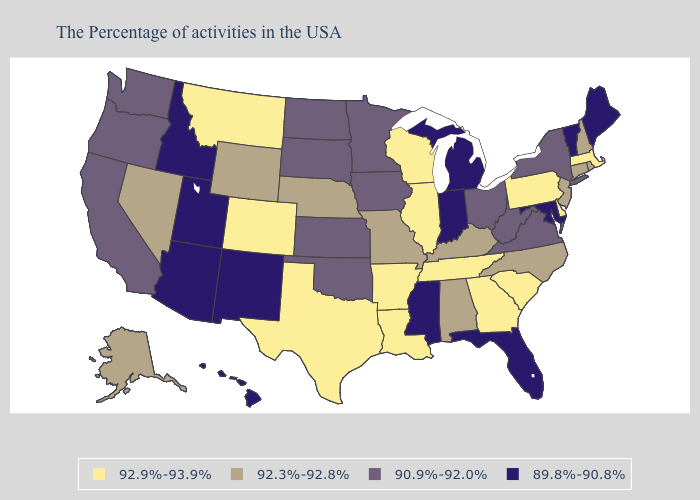Name the states that have a value in the range 90.9%-92.0%?
Short answer required. New York, Virginia, West Virginia, Ohio, Minnesota, Iowa, Kansas, Oklahoma, South Dakota, North Dakota, California, Washington, Oregon. Name the states that have a value in the range 92.9%-93.9%?
Write a very short answer. Massachusetts, Delaware, Pennsylvania, South Carolina, Georgia, Tennessee, Wisconsin, Illinois, Louisiana, Arkansas, Texas, Colorado, Montana. Does the map have missing data?
Short answer required. No. Name the states that have a value in the range 89.8%-90.8%?
Keep it brief. Maine, Vermont, Maryland, Florida, Michigan, Indiana, Mississippi, New Mexico, Utah, Arizona, Idaho, Hawaii. What is the value of Louisiana?
Be succinct. 92.9%-93.9%. Among the states that border Oregon , which have the lowest value?
Answer briefly. Idaho. Name the states that have a value in the range 89.8%-90.8%?
Concise answer only. Maine, Vermont, Maryland, Florida, Michigan, Indiana, Mississippi, New Mexico, Utah, Arizona, Idaho, Hawaii. What is the highest value in the Northeast ?
Write a very short answer. 92.9%-93.9%. Name the states that have a value in the range 92.3%-92.8%?
Answer briefly. Rhode Island, New Hampshire, Connecticut, New Jersey, North Carolina, Kentucky, Alabama, Missouri, Nebraska, Wyoming, Nevada, Alaska. Does the first symbol in the legend represent the smallest category?
Write a very short answer. No. What is the value of Illinois?
Quick response, please. 92.9%-93.9%. Does Massachusetts have the highest value in the Northeast?
Short answer required. Yes. Does Utah have the lowest value in the West?
Give a very brief answer. Yes. Among the states that border New Hampshire , which have the lowest value?
Be succinct. Maine, Vermont. Name the states that have a value in the range 89.8%-90.8%?
Write a very short answer. Maine, Vermont, Maryland, Florida, Michigan, Indiana, Mississippi, New Mexico, Utah, Arizona, Idaho, Hawaii. 